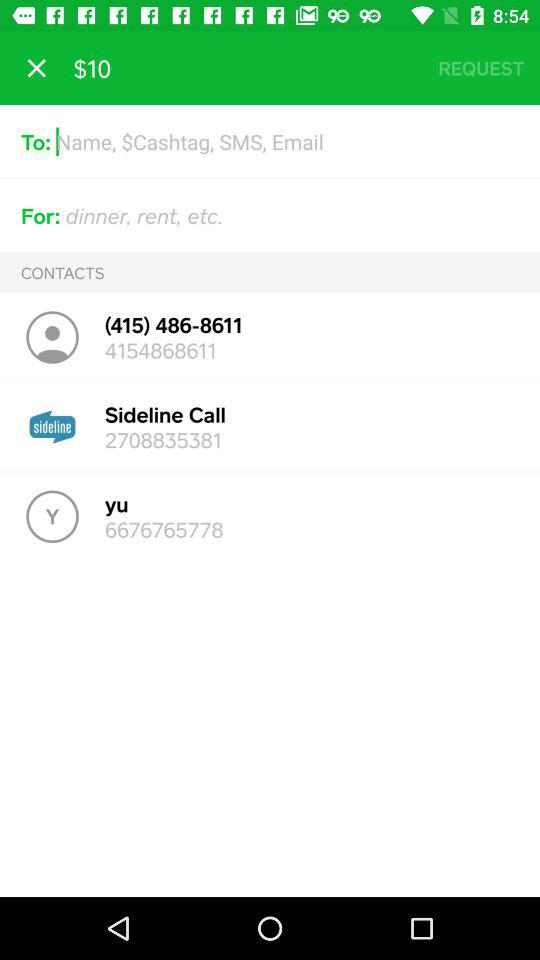On the "yu" call, what number is displayed? The displayed number is 6676765778. 